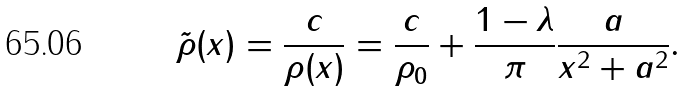<formula> <loc_0><loc_0><loc_500><loc_500>\tilde { \rho } ( x ) = \frac { c } { \rho ( x ) } = \frac { c } { \rho _ { 0 } } + \frac { 1 - \lambda } { \pi } \frac { a } { x ^ { 2 } + a ^ { 2 } } .</formula> 